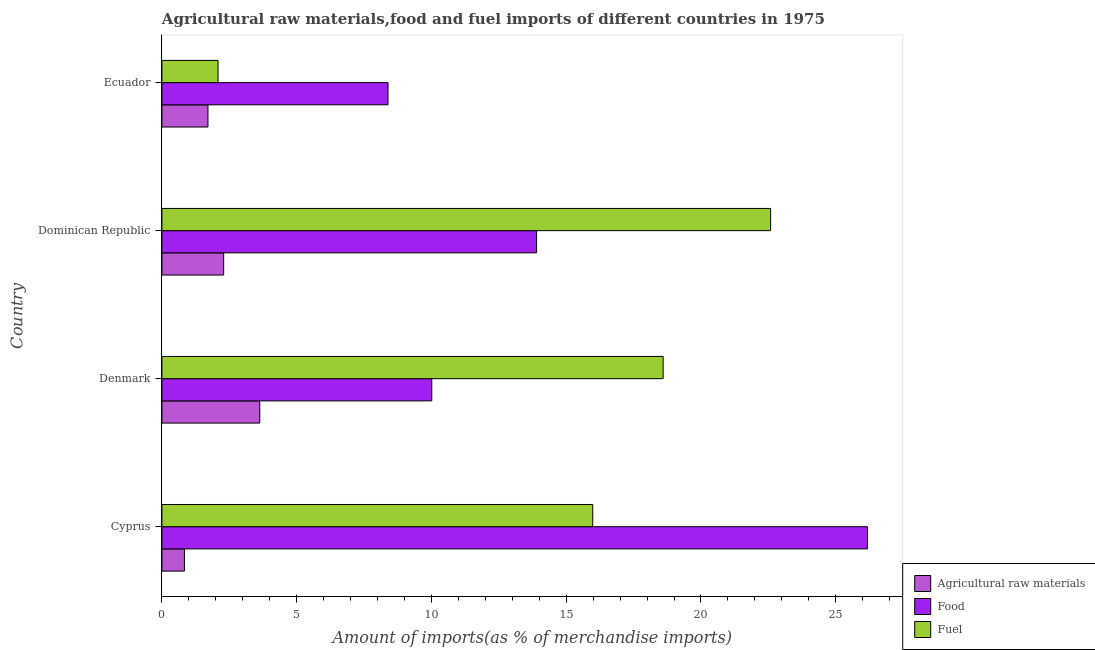Are the number of bars on each tick of the Y-axis equal?
Provide a short and direct response. Yes. How many bars are there on the 1st tick from the top?
Provide a succinct answer. 3. How many bars are there on the 1st tick from the bottom?
Offer a very short reply. 3. What is the label of the 2nd group of bars from the top?
Offer a terse response. Dominican Republic. What is the percentage of fuel imports in Denmark?
Provide a short and direct response. 18.6. Across all countries, what is the maximum percentage of fuel imports?
Keep it short and to the point. 22.58. Across all countries, what is the minimum percentage of raw materials imports?
Provide a succinct answer. 0.84. In which country was the percentage of food imports maximum?
Ensure brevity in your answer.  Cyprus. In which country was the percentage of raw materials imports minimum?
Keep it short and to the point. Cyprus. What is the total percentage of food imports in the graph?
Your answer should be compact. 58.48. What is the difference between the percentage of raw materials imports in Dominican Republic and that in Ecuador?
Your answer should be very brief. 0.58. What is the difference between the percentage of food imports in Dominican Republic and the percentage of fuel imports in Cyprus?
Make the answer very short. -2.08. What is the average percentage of fuel imports per country?
Offer a very short reply. 14.81. What is the difference between the percentage of raw materials imports and percentage of food imports in Dominican Republic?
Ensure brevity in your answer.  -11.61. What is the ratio of the percentage of food imports in Cyprus to that in Ecuador?
Give a very brief answer. 3.12. Is the percentage of fuel imports in Cyprus less than that in Dominican Republic?
Offer a very short reply. Yes. Is the difference between the percentage of food imports in Cyprus and Dominican Republic greater than the difference between the percentage of raw materials imports in Cyprus and Dominican Republic?
Provide a short and direct response. Yes. What is the difference between the highest and the second highest percentage of raw materials imports?
Provide a short and direct response. 1.34. What is the difference between the highest and the lowest percentage of raw materials imports?
Offer a very short reply. 2.8. What does the 1st bar from the top in Cyprus represents?
Provide a short and direct response. Fuel. What does the 1st bar from the bottom in Dominican Republic represents?
Your response must be concise. Agricultural raw materials. How many countries are there in the graph?
Offer a terse response. 4. Are the values on the major ticks of X-axis written in scientific E-notation?
Your response must be concise. No. Where does the legend appear in the graph?
Give a very brief answer. Bottom right. How are the legend labels stacked?
Make the answer very short. Vertical. What is the title of the graph?
Keep it short and to the point. Agricultural raw materials,food and fuel imports of different countries in 1975. What is the label or title of the X-axis?
Your answer should be compact. Amount of imports(as % of merchandise imports). What is the Amount of imports(as % of merchandise imports) of Agricultural raw materials in Cyprus?
Offer a very short reply. 0.84. What is the Amount of imports(as % of merchandise imports) of Food in Cyprus?
Offer a terse response. 26.18. What is the Amount of imports(as % of merchandise imports) in Fuel in Cyprus?
Your response must be concise. 15.99. What is the Amount of imports(as % of merchandise imports) of Agricultural raw materials in Denmark?
Make the answer very short. 3.63. What is the Amount of imports(as % of merchandise imports) of Food in Denmark?
Make the answer very short. 10.01. What is the Amount of imports(as % of merchandise imports) of Fuel in Denmark?
Ensure brevity in your answer.  18.6. What is the Amount of imports(as % of merchandise imports) in Agricultural raw materials in Dominican Republic?
Offer a terse response. 2.29. What is the Amount of imports(as % of merchandise imports) of Food in Dominican Republic?
Provide a short and direct response. 13.9. What is the Amount of imports(as % of merchandise imports) in Fuel in Dominican Republic?
Your answer should be compact. 22.58. What is the Amount of imports(as % of merchandise imports) in Agricultural raw materials in Ecuador?
Give a very brief answer. 1.71. What is the Amount of imports(as % of merchandise imports) in Food in Ecuador?
Your answer should be very brief. 8.39. What is the Amount of imports(as % of merchandise imports) of Fuel in Ecuador?
Make the answer very short. 2.08. Across all countries, what is the maximum Amount of imports(as % of merchandise imports) of Agricultural raw materials?
Provide a succinct answer. 3.63. Across all countries, what is the maximum Amount of imports(as % of merchandise imports) in Food?
Keep it short and to the point. 26.18. Across all countries, what is the maximum Amount of imports(as % of merchandise imports) of Fuel?
Give a very brief answer. 22.58. Across all countries, what is the minimum Amount of imports(as % of merchandise imports) of Agricultural raw materials?
Make the answer very short. 0.84. Across all countries, what is the minimum Amount of imports(as % of merchandise imports) of Food?
Give a very brief answer. 8.39. Across all countries, what is the minimum Amount of imports(as % of merchandise imports) of Fuel?
Your answer should be compact. 2.08. What is the total Amount of imports(as % of merchandise imports) of Agricultural raw materials in the graph?
Provide a short and direct response. 8.47. What is the total Amount of imports(as % of merchandise imports) in Food in the graph?
Your answer should be very brief. 58.48. What is the total Amount of imports(as % of merchandise imports) in Fuel in the graph?
Ensure brevity in your answer.  59.25. What is the difference between the Amount of imports(as % of merchandise imports) of Agricultural raw materials in Cyprus and that in Denmark?
Provide a succinct answer. -2.8. What is the difference between the Amount of imports(as % of merchandise imports) of Food in Cyprus and that in Denmark?
Offer a terse response. 16.16. What is the difference between the Amount of imports(as % of merchandise imports) in Fuel in Cyprus and that in Denmark?
Make the answer very short. -2.61. What is the difference between the Amount of imports(as % of merchandise imports) in Agricultural raw materials in Cyprus and that in Dominican Republic?
Offer a very short reply. -1.46. What is the difference between the Amount of imports(as % of merchandise imports) of Food in Cyprus and that in Dominican Republic?
Ensure brevity in your answer.  12.27. What is the difference between the Amount of imports(as % of merchandise imports) in Fuel in Cyprus and that in Dominican Republic?
Offer a very short reply. -6.6. What is the difference between the Amount of imports(as % of merchandise imports) of Agricultural raw materials in Cyprus and that in Ecuador?
Offer a very short reply. -0.87. What is the difference between the Amount of imports(as % of merchandise imports) in Food in Cyprus and that in Ecuador?
Ensure brevity in your answer.  17.79. What is the difference between the Amount of imports(as % of merchandise imports) of Fuel in Cyprus and that in Ecuador?
Your answer should be very brief. 13.9. What is the difference between the Amount of imports(as % of merchandise imports) in Agricultural raw materials in Denmark and that in Dominican Republic?
Your answer should be very brief. 1.34. What is the difference between the Amount of imports(as % of merchandise imports) of Food in Denmark and that in Dominican Republic?
Make the answer very short. -3.89. What is the difference between the Amount of imports(as % of merchandise imports) of Fuel in Denmark and that in Dominican Republic?
Make the answer very short. -3.99. What is the difference between the Amount of imports(as % of merchandise imports) of Agricultural raw materials in Denmark and that in Ecuador?
Offer a terse response. 1.92. What is the difference between the Amount of imports(as % of merchandise imports) of Food in Denmark and that in Ecuador?
Your answer should be compact. 1.62. What is the difference between the Amount of imports(as % of merchandise imports) in Fuel in Denmark and that in Ecuador?
Make the answer very short. 16.51. What is the difference between the Amount of imports(as % of merchandise imports) of Agricultural raw materials in Dominican Republic and that in Ecuador?
Your answer should be compact. 0.58. What is the difference between the Amount of imports(as % of merchandise imports) in Food in Dominican Republic and that in Ecuador?
Provide a succinct answer. 5.51. What is the difference between the Amount of imports(as % of merchandise imports) of Fuel in Dominican Republic and that in Ecuador?
Your response must be concise. 20.5. What is the difference between the Amount of imports(as % of merchandise imports) of Agricultural raw materials in Cyprus and the Amount of imports(as % of merchandise imports) of Food in Denmark?
Offer a terse response. -9.18. What is the difference between the Amount of imports(as % of merchandise imports) of Agricultural raw materials in Cyprus and the Amount of imports(as % of merchandise imports) of Fuel in Denmark?
Your response must be concise. -17.76. What is the difference between the Amount of imports(as % of merchandise imports) of Food in Cyprus and the Amount of imports(as % of merchandise imports) of Fuel in Denmark?
Keep it short and to the point. 7.58. What is the difference between the Amount of imports(as % of merchandise imports) of Agricultural raw materials in Cyprus and the Amount of imports(as % of merchandise imports) of Food in Dominican Republic?
Your answer should be compact. -13.07. What is the difference between the Amount of imports(as % of merchandise imports) in Agricultural raw materials in Cyprus and the Amount of imports(as % of merchandise imports) in Fuel in Dominican Republic?
Make the answer very short. -21.75. What is the difference between the Amount of imports(as % of merchandise imports) in Food in Cyprus and the Amount of imports(as % of merchandise imports) in Fuel in Dominican Republic?
Your answer should be compact. 3.59. What is the difference between the Amount of imports(as % of merchandise imports) of Agricultural raw materials in Cyprus and the Amount of imports(as % of merchandise imports) of Food in Ecuador?
Your response must be concise. -7.55. What is the difference between the Amount of imports(as % of merchandise imports) in Agricultural raw materials in Cyprus and the Amount of imports(as % of merchandise imports) in Fuel in Ecuador?
Make the answer very short. -1.25. What is the difference between the Amount of imports(as % of merchandise imports) of Food in Cyprus and the Amount of imports(as % of merchandise imports) of Fuel in Ecuador?
Give a very brief answer. 24.09. What is the difference between the Amount of imports(as % of merchandise imports) in Agricultural raw materials in Denmark and the Amount of imports(as % of merchandise imports) in Food in Dominican Republic?
Give a very brief answer. -10.27. What is the difference between the Amount of imports(as % of merchandise imports) of Agricultural raw materials in Denmark and the Amount of imports(as % of merchandise imports) of Fuel in Dominican Republic?
Provide a short and direct response. -18.95. What is the difference between the Amount of imports(as % of merchandise imports) in Food in Denmark and the Amount of imports(as % of merchandise imports) in Fuel in Dominican Republic?
Your answer should be very brief. -12.57. What is the difference between the Amount of imports(as % of merchandise imports) of Agricultural raw materials in Denmark and the Amount of imports(as % of merchandise imports) of Food in Ecuador?
Keep it short and to the point. -4.76. What is the difference between the Amount of imports(as % of merchandise imports) in Agricultural raw materials in Denmark and the Amount of imports(as % of merchandise imports) in Fuel in Ecuador?
Your answer should be very brief. 1.55. What is the difference between the Amount of imports(as % of merchandise imports) of Food in Denmark and the Amount of imports(as % of merchandise imports) of Fuel in Ecuador?
Provide a short and direct response. 7.93. What is the difference between the Amount of imports(as % of merchandise imports) of Agricultural raw materials in Dominican Republic and the Amount of imports(as % of merchandise imports) of Food in Ecuador?
Keep it short and to the point. -6.1. What is the difference between the Amount of imports(as % of merchandise imports) of Agricultural raw materials in Dominican Republic and the Amount of imports(as % of merchandise imports) of Fuel in Ecuador?
Offer a terse response. 0.21. What is the difference between the Amount of imports(as % of merchandise imports) in Food in Dominican Republic and the Amount of imports(as % of merchandise imports) in Fuel in Ecuador?
Your response must be concise. 11.82. What is the average Amount of imports(as % of merchandise imports) in Agricultural raw materials per country?
Provide a succinct answer. 2.12. What is the average Amount of imports(as % of merchandise imports) of Food per country?
Offer a terse response. 14.62. What is the average Amount of imports(as % of merchandise imports) in Fuel per country?
Offer a terse response. 14.81. What is the difference between the Amount of imports(as % of merchandise imports) in Agricultural raw materials and Amount of imports(as % of merchandise imports) in Food in Cyprus?
Provide a short and direct response. -25.34. What is the difference between the Amount of imports(as % of merchandise imports) of Agricultural raw materials and Amount of imports(as % of merchandise imports) of Fuel in Cyprus?
Offer a terse response. -15.15. What is the difference between the Amount of imports(as % of merchandise imports) in Food and Amount of imports(as % of merchandise imports) in Fuel in Cyprus?
Keep it short and to the point. 10.19. What is the difference between the Amount of imports(as % of merchandise imports) of Agricultural raw materials and Amount of imports(as % of merchandise imports) of Food in Denmark?
Your answer should be very brief. -6.38. What is the difference between the Amount of imports(as % of merchandise imports) of Agricultural raw materials and Amount of imports(as % of merchandise imports) of Fuel in Denmark?
Offer a very short reply. -14.97. What is the difference between the Amount of imports(as % of merchandise imports) of Food and Amount of imports(as % of merchandise imports) of Fuel in Denmark?
Your answer should be compact. -8.58. What is the difference between the Amount of imports(as % of merchandise imports) of Agricultural raw materials and Amount of imports(as % of merchandise imports) of Food in Dominican Republic?
Keep it short and to the point. -11.61. What is the difference between the Amount of imports(as % of merchandise imports) in Agricultural raw materials and Amount of imports(as % of merchandise imports) in Fuel in Dominican Republic?
Offer a terse response. -20.29. What is the difference between the Amount of imports(as % of merchandise imports) of Food and Amount of imports(as % of merchandise imports) of Fuel in Dominican Republic?
Provide a short and direct response. -8.68. What is the difference between the Amount of imports(as % of merchandise imports) in Agricultural raw materials and Amount of imports(as % of merchandise imports) in Food in Ecuador?
Offer a very short reply. -6.68. What is the difference between the Amount of imports(as % of merchandise imports) of Agricultural raw materials and Amount of imports(as % of merchandise imports) of Fuel in Ecuador?
Give a very brief answer. -0.37. What is the difference between the Amount of imports(as % of merchandise imports) of Food and Amount of imports(as % of merchandise imports) of Fuel in Ecuador?
Your answer should be very brief. 6.31. What is the ratio of the Amount of imports(as % of merchandise imports) of Agricultural raw materials in Cyprus to that in Denmark?
Your answer should be compact. 0.23. What is the ratio of the Amount of imports(as % of merchandise imports) in Food in Cyprus to that in Denmark?
Make the answer very short. 2.61. What is the ratio of the Amount of imports(as % of merchandise imports) in Fuel in Cyprus to that in Denmark?
Offer a very short reply. 0.86. What is the ratio of the Amount of imports(as % of merchandise imports) of Agricultural raw materials in Cyprus to that in Dominican Republic?
Your answer should be very brief. 0.36. What is the ratio of the Amount of imports(as % of merchandise imports) of Food in Cyprus to that in Dominican Republic?
Offer a very short reply. 1.88. What is the ratio of the Amount of imports(as % of merchandise imports) in Fuel in Cyprus to that in Dominican Republic?
Your response must be concise. 0.71. What is the ratio of the Amount of imports(as % of merchandise imports) in Agricultural raw materials in Cyprus to that in Ecuador?
Offer a terse response. 0.49. What is the ratio of the Amount of imports(as % of merchandise imports) of Food in Cyprus to that in Ecuador?
Offer a terse response. 3.12. What is the ratio of the Amount of imports(as % of merchandise imports) in Fuel in Cyprus to that in Ecuador?
Provide a succinct answer. 7.67. What is the ratio of the Amount of imports(as % of merchandise imports) in Agricultural raw materials in Denmark to that in Dominican Republic?
Make the answer very short. 1.58. What is the ratio of the Amount of imports(as % of merchandise imports) of Food in Denmark to that in Dominican Republic?
Make the answer very short. 0.72. What is the ratio of the Amount of imports(as % of merchandise imports) of Fuel in Denmark to that in Dominican Republic?
Make the answer very short. 0.82. What is the ratio of the Amount of imports(as % of merchandise imports) of Agricultural raw materials in Denmark to that in Ecuador?
Offer a terse response. 2.12. What is the ratio of the Amount of imports(as % of merchandise imports) of Food in Denmark to that in Ecuador?
Give a very brief answer. 1.19. What is the ratio of the Amount of imports(as % of merchandise imports) of Fuel in Denmark to that in Ecuador?
Your answer should be very brief. 8.93. What is the ratio of the Amount of imports(as % of merchandise imports) in Agricultural raw materials in Dominican Republic to that in Ecuador?
Offer a very short reply. 1.34. What is the ratio of the Amount of imports(as % of merchandise imports) in Food in Dominican Republic to that in Ecuador?
Your response must be concise. 1.66. What is the ratio of the Amount of imports(as % of merchandise imports) in Fuel in Dominican Republic to that in Ecuador?
Make the answer very short. 10.84. What is the difference between the highest and the second highest Amount of imports(as % of merchandise imports) in Agricultural raw materials?
Your response must be concise. 1.34. What is the difference between the highest and the second highest Amount of imports(as % of merchandise imports) of Food?
Your answer should be very brief. 12.27. What is the difference between the highest and the second highest Amount of imports(as % of merchandise imports) of Fuel?
Keep it short and to the point. 3.99. What is the difference between the highest and the lowest Amount of imports(as % of merchandise imports) in Agricultural raw materials?
Provide a succinct answer. 2.8. What is the difference between the highest and the lowest Amount of imports(as % of merchandise imports) in Food?
Ensure brevity in your answer.  17.79. What is the difference between the highest and the lowest Amount of imports(as % of merchandise imports) in Fuel?
Offer a terse response. 20.5. 